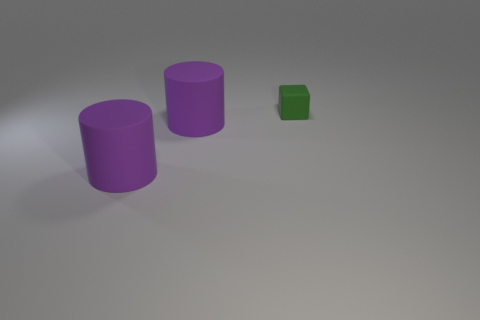Is there any other thing that is the same size as the green thing?
Keep it short and to the point. No. What number of rubber things are either green objects or big purple things?
Give a very brief answer. 3. Is the number of large cyan metal spheres less than the number of big purple matte objects?
Offer a very short reply. Yes. Are there any other things of the same color as the tiny cube?
Provide a short and direct response. No. How many other objects are there of the same size as the green thing?
Your answer should be very brief. 0. What number of other things are the same shape as the small rubber thing?
Your answer should be compact. 0. Are there any things made of the same material as the cube?
Your response must be concise. Yes. What size is the green matte thing?
Keep it short and to the point. Small. What number of objects are on the left side of the green rubber object?
Ensure brevity in your answer.  2. What number of other tiny cubes are the same color as the block?
Make the answer very short. 0. 